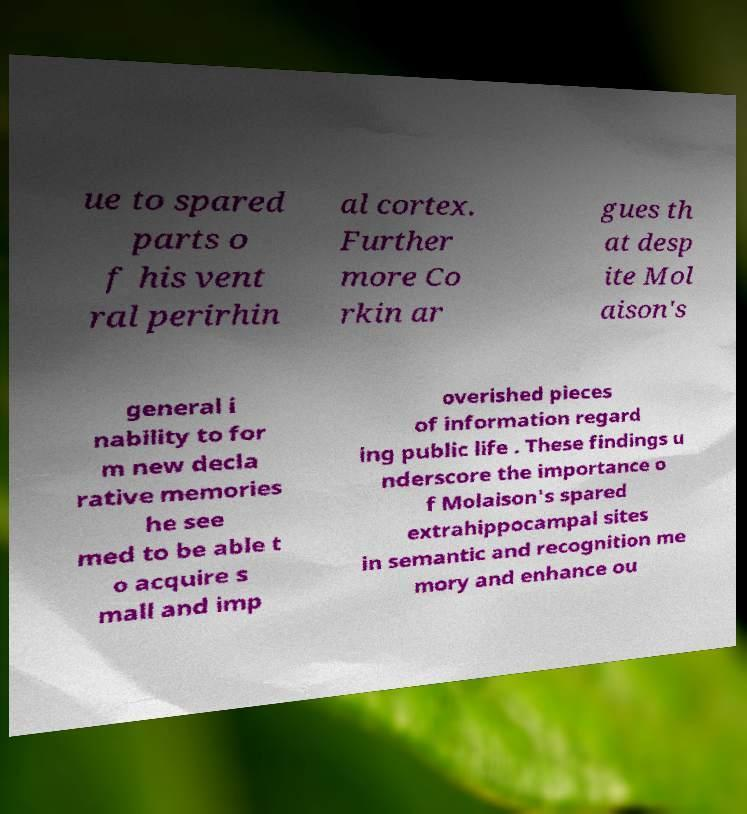There's text embedded in this image that I need extracted. Can you transcribe it verbatim? ue to spared parts o f his vent ral perirhin al cortex. Further more Co rkin ar gues th at desp ite Mol aison's general i nability to for m new decla rative memories he see med to be able t o acquire s mall and imp overished pieces of information regard ing public life . These findings u nderscore the importance o f Molaison's spared extrahippocampal sites in semantic and recognition me mory and enhance ou 